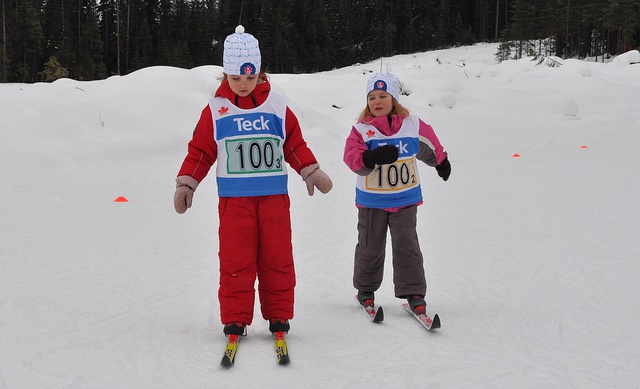Describe the objects in this image and their specific colors. I can see people in black, brown, maroon, blue, and darkgray tones, people in black, darkgray, and blue tones, skis in black, darkgray, gray, and brown tones, and skis in black, gray, olive, and darkgray tones in this image. 